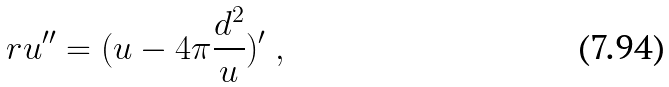<formula> <loc_0><loc_0><loc_500><loc_500>r u ^ { \prime \prime } = ( u - 4 \pi \frac { d ^ { 2 } } { u } ) ^ { \prime } \ ,</formula> 